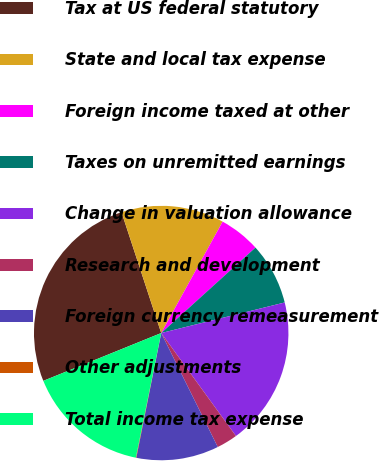Convert chart to OTSL. <chart><loc_0><loc_0><loc_500><loc_500><pie_chart><fcel>Tax at US federal statutory<fcel>State and local tax expense<fcel>Foreign income taxed at other<fcel>Taxes on unremitted earnings<fcel>Change in valuation allowance<fcel>Research and development<fcel>Foreign currency remeasurement<fcel>Other adjustments<fcel>Total income tax expense<nl><fcel>26.08%<fcel>13.07%<fcel>5.26%<fcel>7.86%<fcel>18.87%<fcel>2.66%<fcel>10.47%<fcel>0.06%<fcel>15.67%<nl></chart> 